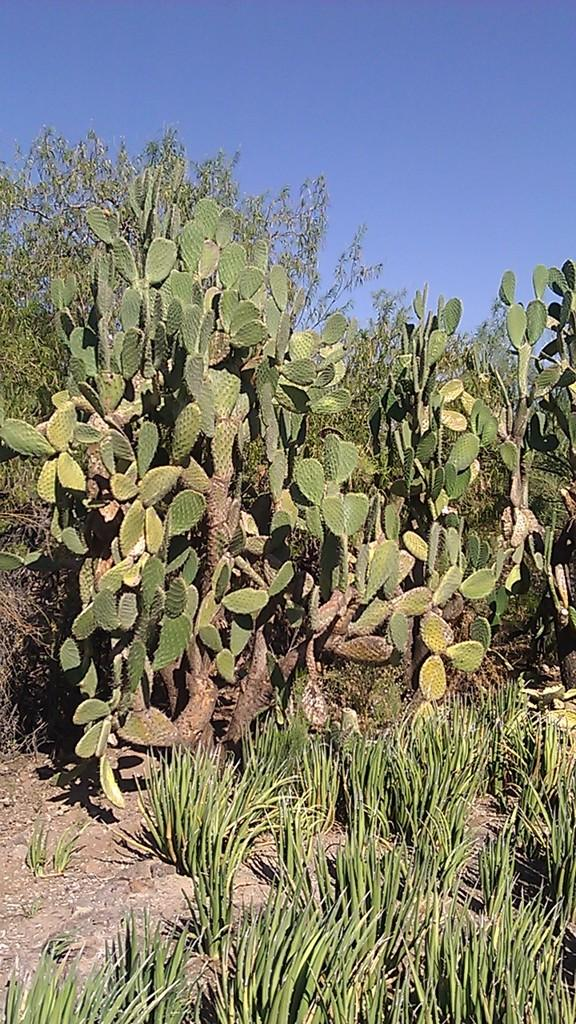What type of living organisms can be seen in the image? Plants can be seen in the image. What color are the plants in the image? The plants are green in color. What part of the natural environment is visible in the image? The sky is visible in the image. What color is the sky in the image? The sky is blue in color. How many children are wearing skirts in the image? There are no children or skirts present in the image; it features plants and a blue sky. 